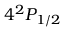<formula> <loc_0><loc_0><loc_500><loc_500>4 ^ { 2 } P _ { 1 / 2 }</formula> 